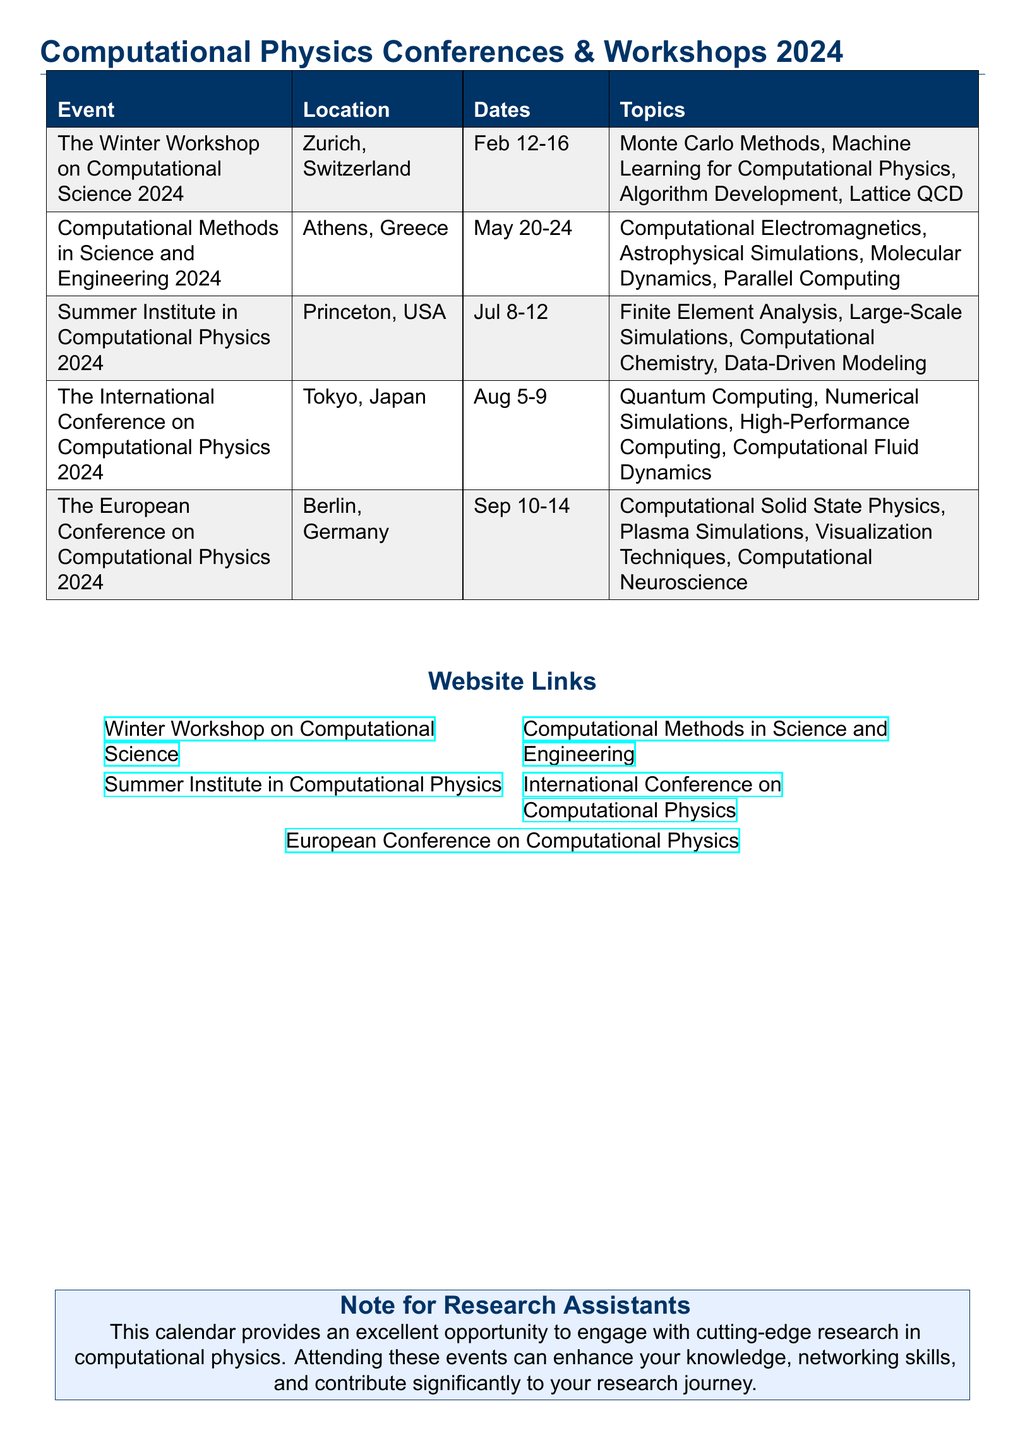What is the location of the Winter Workshop on Computational Science 2024? The location is listed in the document under the relevant event, which is Zurich, Switzerland.
Answer: Zurich, Switzerland When is the Summer Institute in Computational Physics 2024 scheduled? The dates for this event can be found in the document, which states it is from July 8 to July 12.
Answer: July 8-12 What topic is covered in the International Conference on Computational Physics 2024? The document lists several topics, one of which is Quantum Computing.
Answer: Quantum Computing Which event takes place in Berlin, Germany? This information refers to the location of an event mentioned in the document, specifically The European Conference on Computational Physics 2024.
Answer: The European Conference on Computational Physics 2024 How many events are listed in the calendar? The document enumerates each event, detailing different conferences and workshops. Counting them gives a total of five events.
Answer: 5 What is a primary focus of the Computational Methods in Science and Engineering 2024? The document specifies several topics, one of which is Computational Electromagnetics.
Answer: Computational Electromagnetics Which month hosts the International Conference on Computational Physics 2024? The month is mentioned in the date section of the document, which indicates it is in August.
Answer: August What is the website link for the Winter Workshop on Computational Science? The document provides a hyperlink to the event's web address, specifically stating "Winter Workshop on Computational Science".
Answer: https://www.wwcs2024.ch 